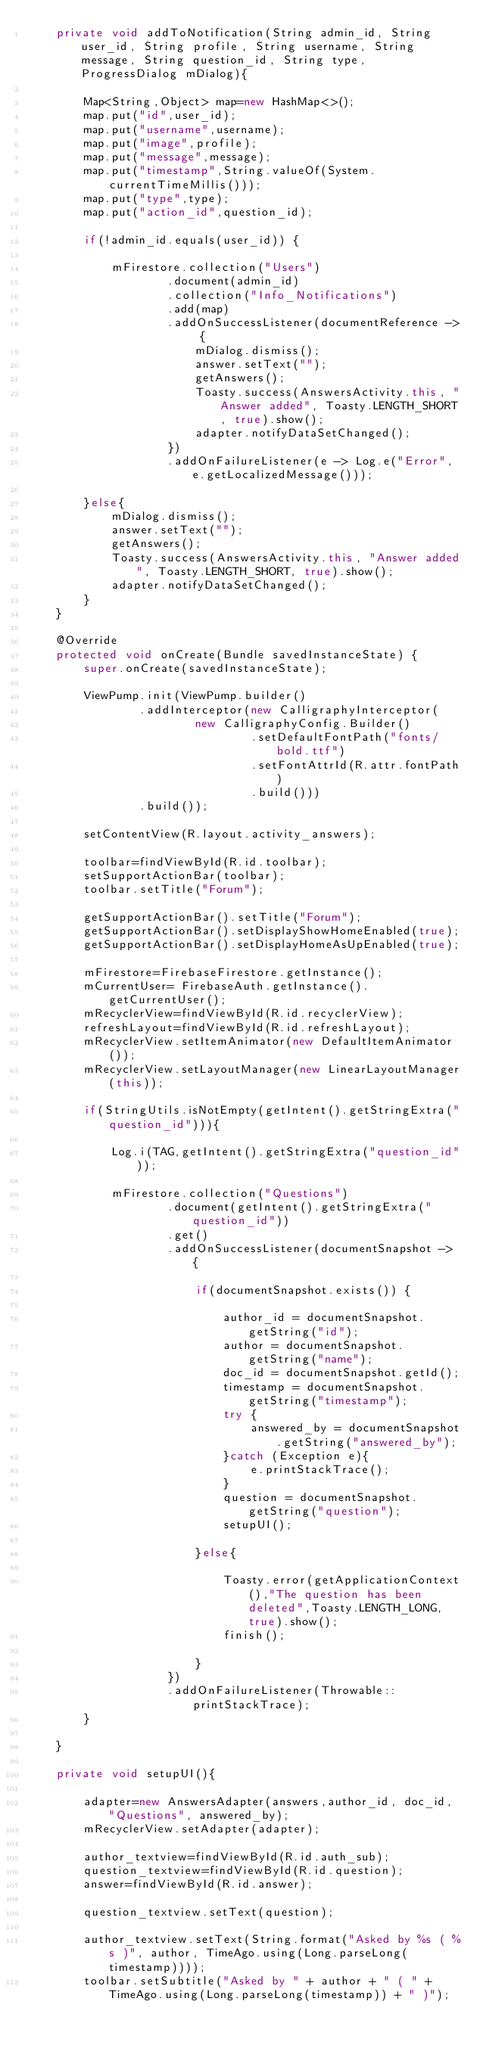Convert code to text. <code><loc_0><loc_0><loc_500><loc_500><_Java_>    private void addToNotification(String admin_id, String user_id, String profile, String username, String message, String question_id, String type, ProgressDialog mDialog){

        Map<String,Object> map=new HashMap<>();
        map.put("id",user_id);
        map.put("username",username);
        map.put("image",profile);
        map.put("message",message);
        map.put("timestamp",String.valueOf(System.currentTimeMillis()));
        map.put("type",type);
        map.put("action_id",question_id);

        if(!admin_id.equals(user_id)) {

            mFirestore.collection("Users")
                    .document(admin_id)
                    .collection("Info_Notifications")
                    .add(map)
                    .addOnSuccessListener(documentReference -> {
                        mDialog.dismiss();
                        answer.setText("");
                        getAnswers();
                        Toasty.success(AnswersActivity.this, "Answer added", Toasty.LENGTH_SHORT, true).show();
                        adapter.notifyDataSetChanged();
                    })
                    .addOnFailureListener(e -> Log.e("Error", e.getLocalizedMessage()));

        }else{
            mDialog.dismiss();
            answer.setText("");
            getAnswers();
            Toasty.success(AnswersActivity.this, "Answer added", Toasty.LENGTH_SHORT, true).show();
            adapter.notifyDataSetChanged();
        }
    }

    @Override
    protected void onCreate(Bundle savedInstanceState) {
        super.onCreate(savedInstanceState);

        ViewPump.init(ViewPump.builder()
                .addInterceptor(new CalligraphyInterceptor(
                        new CalligraphyConfig.Builder()
                                .setDefaultFontPath("fonts/bold.ttf")
                                .setFontAttrId(R.attr.fontPath)
                                .build()))
                .build());
        
        setContentView(R.layout.activity_answers);

        toolbar=findViewById(R.id.toolbar);
        setSupportActionBar(toolbar);
        toolbar.setTitle("Forum");

        getSupportActionBar().setTitle("Forum");
        getSupportActionBar().setDisplayShowHomeEnabled(true);
        getSupportActionBar().setDisplayHomeAsUpEnabled(true);

        mFirestore=FirebaseFirestore.getInstance();
        mCurrentUser= FirebaseAuth.getInstance().getCurrentUser();
        mRecyclerView=findViewById(R.id.recyclerView);
        refreshLayout=findViewById(R.id.refreshLayout);
        mRecyclerView.setItemAnimator(new DefaultItemAnimator());
        mRecyclerView.setLayoutManager(new LinearLayoutManager(this));

        if(StringUtils.isNotEmpty(getIntent().getStringExtra("question_id"))){

            Log.i(TAG,getIntent().getStringExtra("question_id"));

            mFirestore.collection("Questions")
                    .document(getIntent().getStringExtra("question_id"))
                    .get()
                    .addOnSuccessListener(documentSnapshot -> {

                        if(documentSnapshot.exists()) {

                            author_id = documentSnapshot.getString("id");
                            author = documentSnapshot.getString("name");
                            doc_id = documentSnapshot.getId();
                            timestamp = documentSnapshot.getString("timestamp");
                            try {
                                answered_by = documentSnapshot.getString("answered_by");
                            }catch (Exception e){
                                e.printStackTrace();
                            }
                            question = documentSnapshot.getString("question");
                            setupUI();

                        }else{

                            Toasty.error(getApplicationContext(),"The question has been deleted",Toasty.LENGTH_LONG,true).show();
                            finish();

                        }
                    })
                    .addOnFailureListener(Throwable::printStackTrace);
        }

    }

    private void setupUI(){

        adapter=new AnswersAdapter(answers,author_id, doc_id, "Questions", answered_by);
        mRecyclerView.setAdapter(adapter);

        author_textview=findViewById(R.id.auth_sub);
        question_textview=findViewById(R.id.question);
        answer=findViewById(R.id.answer);

        question_textview.setText(question);

        author_textview.setText(String.format("Asked by %s ( %s )", author, TimeAgo.using(Long.parseLong(timestamp))));
        toolbar.setSubtitle("Asked by " + author + " ( " + TimeAgo.using(Long.parseLong(timestamp)) + " )");</code> 